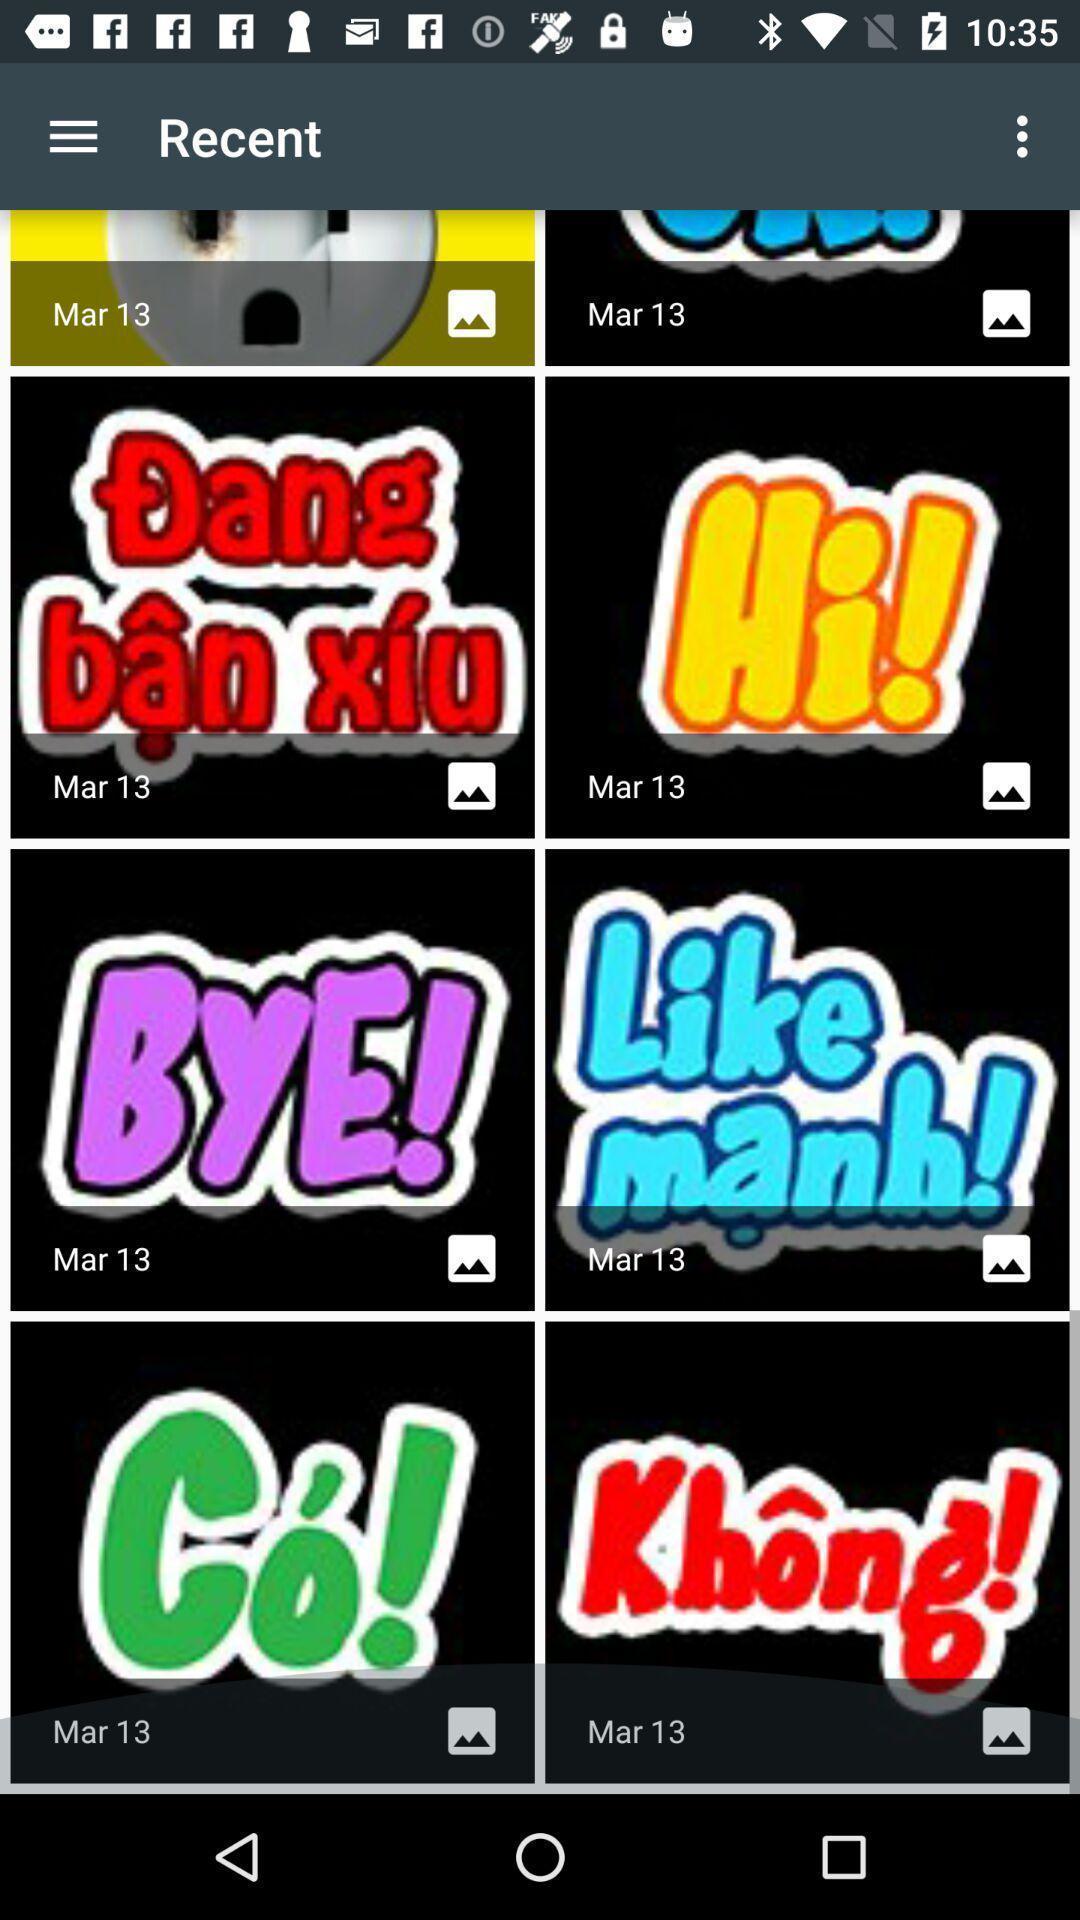Describe this image in words. Various sticker images are displaying. 